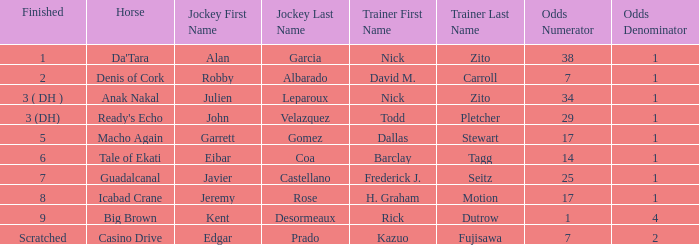What is the final placement for da'tara coached by nick zito? 1.0. 